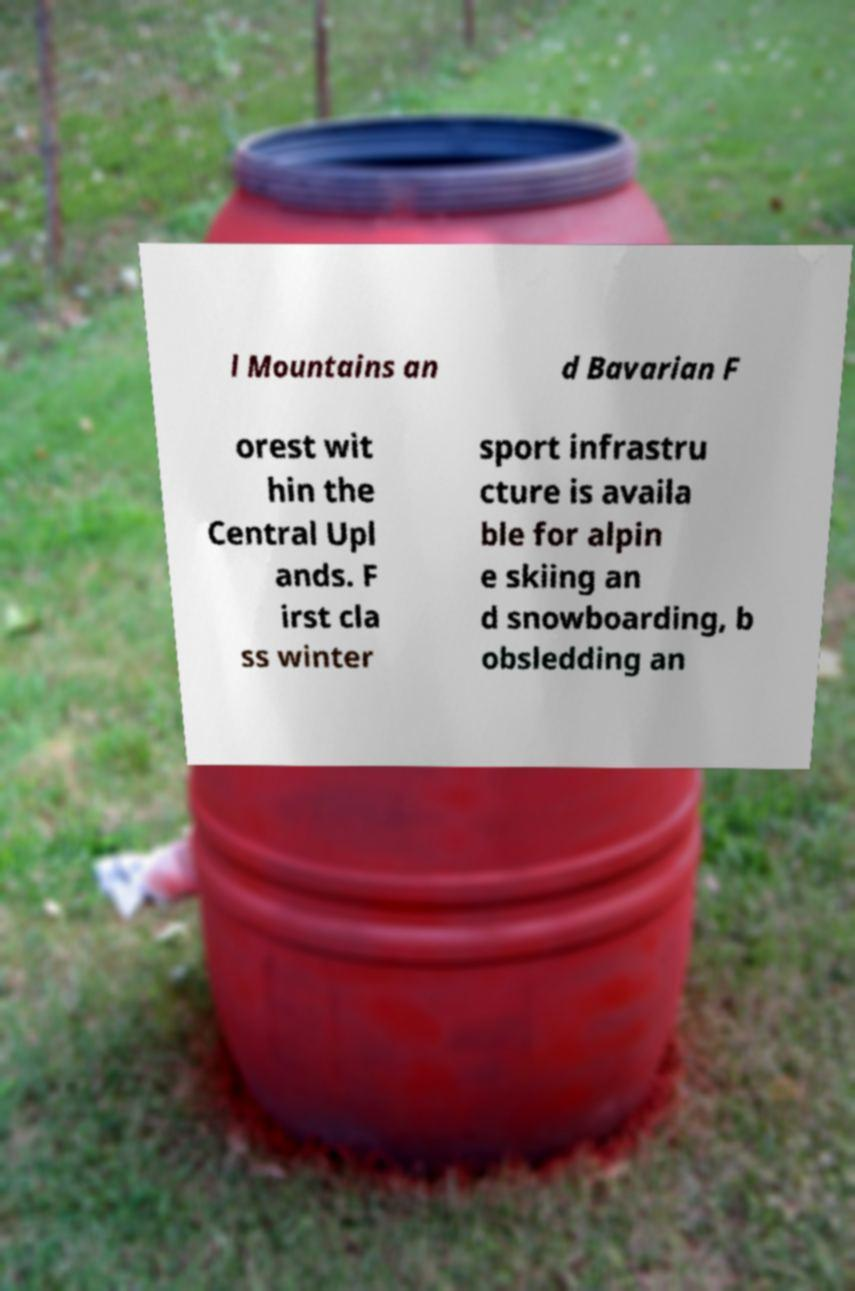Can you accurately transcribe the text from the provided image for me? l Mountains an d Bavarian F orest wit hin the Central Upl ands. F irst cla ss winter sport infrastru cture is availa ble for alpin e skiing an d snowboarding, b obsledding an 